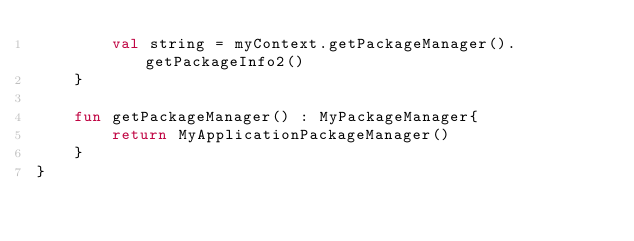<code> <loc_0><loc_0><loc_500><loc_500><_Kotlin_>        val string = myContext.getPackageManager().getPackageInfo2()
    }

    fun getPackageManager() : MyPackageManager{
        return MyApplicationPackageManager()
    }
}</code> 